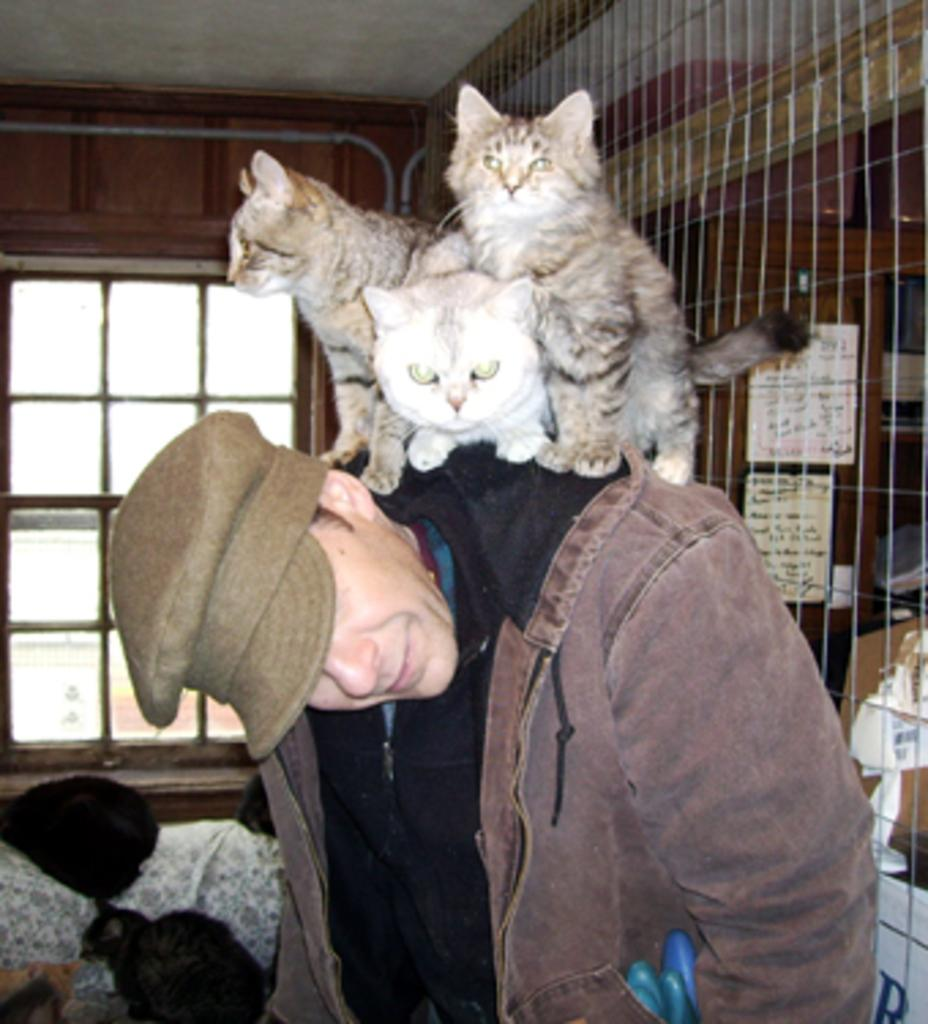How many cats are in the image? There are three cats in the image. What are the cats doing in the image? The cats are standing on a person's shoulder. What other object can be seen in the image? There is a fence visible in the image. What type of honey is the person feeding to the cats in the image? There is no honey present in the image, nor is there any indication that the person is feeding the cats. 